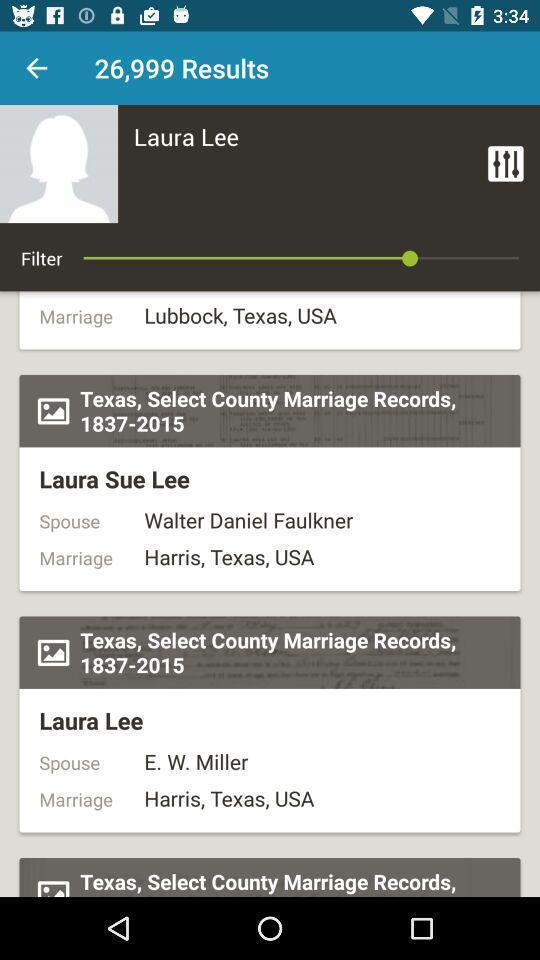Summarize the information in this screenshot. Page shows about recently searched results. 